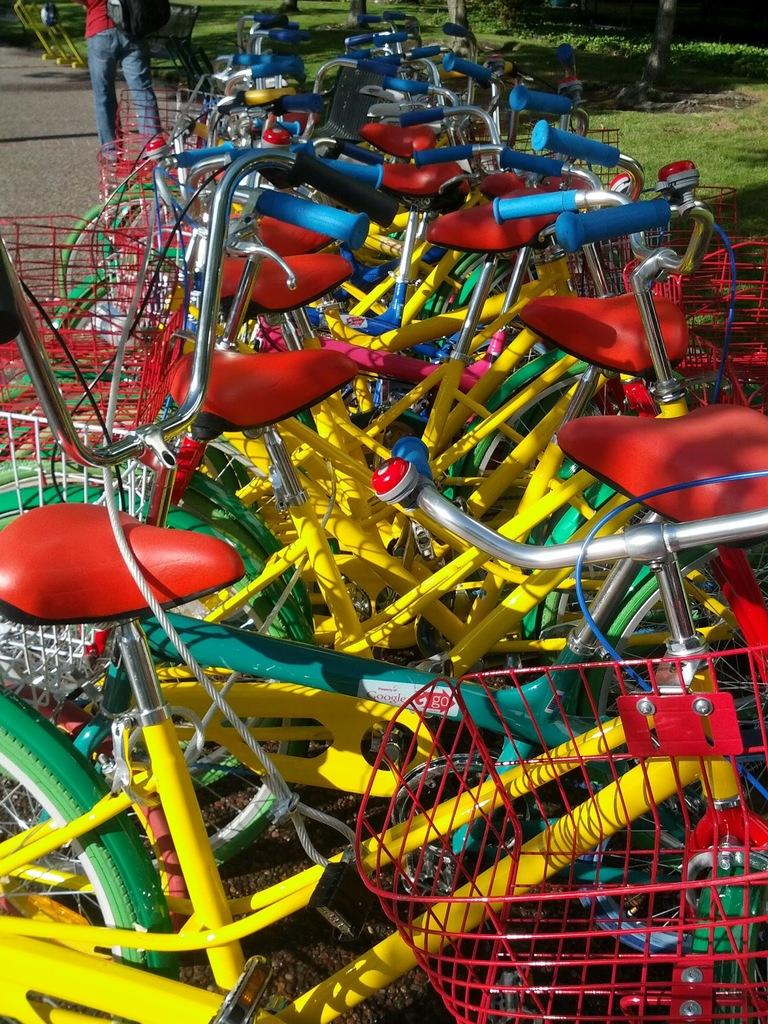What type of vehicles are in the image? There are bicycles with baskets in the image. What additional feature do the bicycles have? The bicycles have ropes. Can you describe the person visible in the image? The human visible at the top of the image is carrying a backpack. What type of surface can be seen in the image? There is a road in the image. What type of vegetation is present in the image? Grass and plants are present in the image. What type of crown is the human wearing in the image? There is no crown visible in the image; the human is carrying a backpack. What is the income of the person riding the bicycle in the image? The income of the person riding the bicycle cannot be determined from the image. 